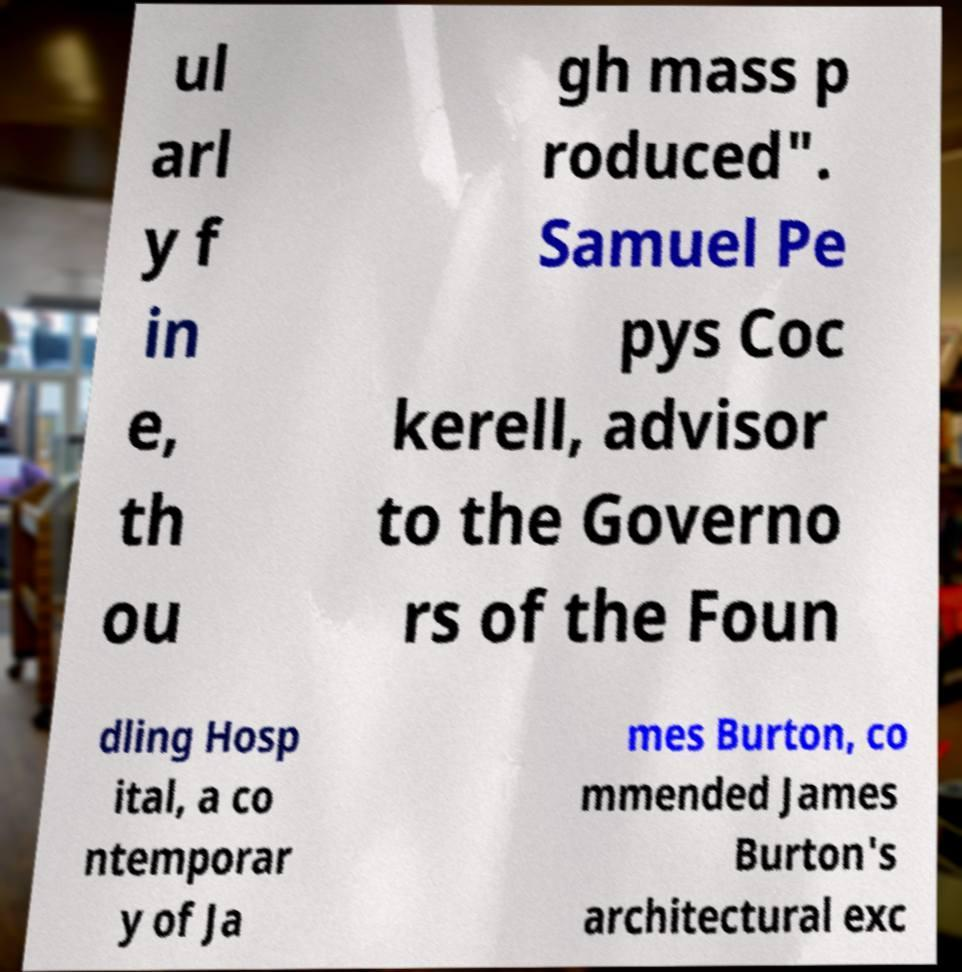Can you accurately transcribe the text from the provided image for me? ul arl y f in e, th ou gh mass p roduced". Samuel Pe pys Coc kerell, advisor to the Governo rs of the Foun dling Hosp ital, a co ntemporar y of Ja mes Burton, co mmended James Burton's architectural exc 